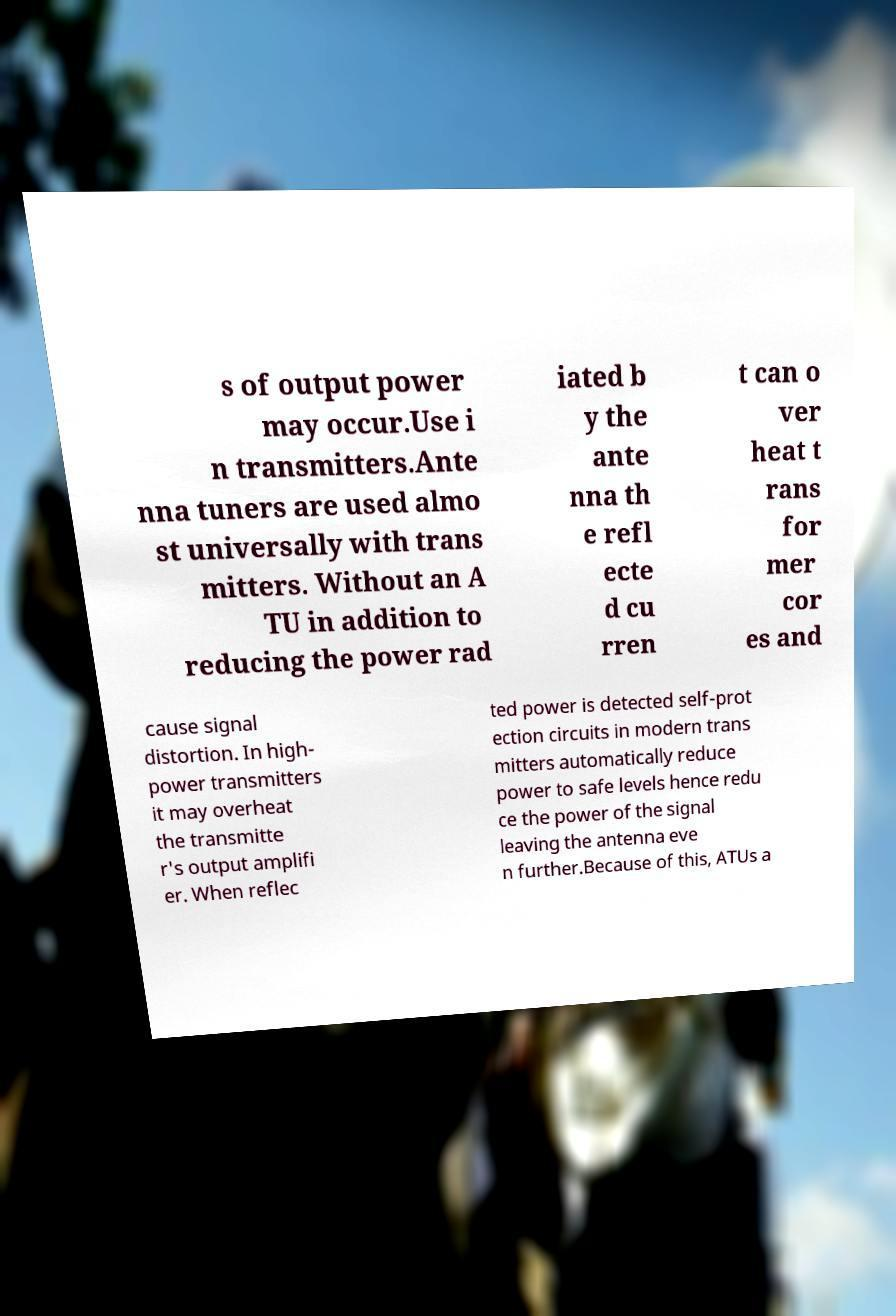There's text embedded in this image that I need extracted. Can you transcribe it verbatim? s of output power may occur.Use i n transmitters.Ante nna tuners are used almo st universally with trans mitters. Without an A TU in addition to reducing the power rad iated b y the ante nna th e refl ecte d cu rren t can o ver heat t rans for mer cor es and cause signal distortion. In high- power transmitters it may overheat the transmitte r's output amplifi er. When reflec ted power is detected self-prot ection circuits in modern trans mitters automatically reduce power to safe levels hence redu ce the power of the signal leaving the antenna eve n further.Because of this, ATUs a 